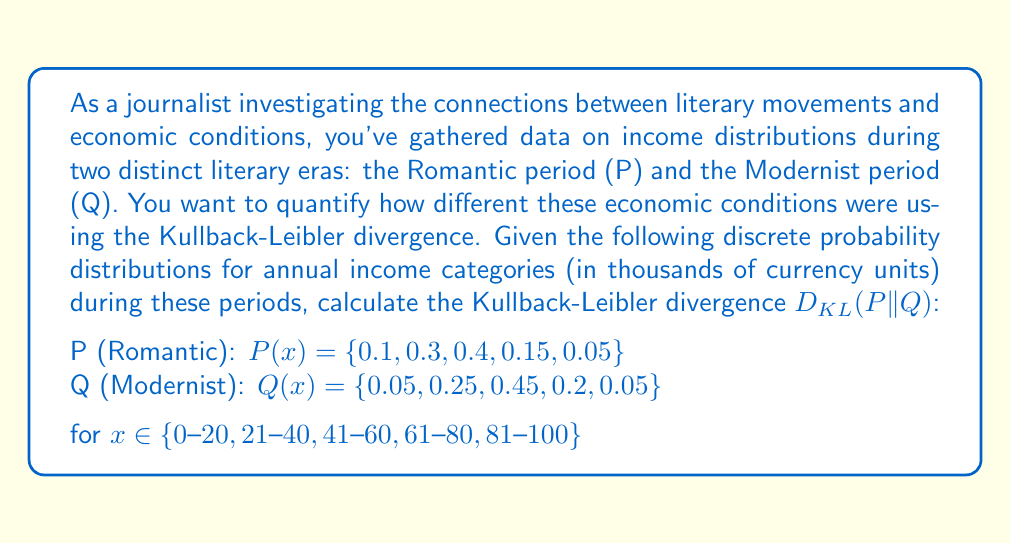Provide a solution to this math problem. To solve this problem, we'll use the formula for Kullback-Leibler divergence for discrete probability distributions:

$$D_{KL}(P||Q) = \sum_{i} P(i) \log\left(\frac{P(i)}{Q(i)}\right)$$

Let's calculate this step-by-step:

1) First, we'll calculate $\frac{P(i)}{Q(i)}$ for each income category:

   $\frac{0.1}{0.05} = 2$
   $\frac{0.3}{0.25} = 1.2$
   $\frac{0.4}{0.45} \approx 0.8889$
   $\frac{0.15}{0.2} = 0.75$
   $\frac{0.05}{0.05} = 1$

2) Now, we'll calculate $\log\left(\frac{P(i)}{Q(i)}\right)$ for each category:

   $\log(2) \approx 0.6931$
   $\log(1.2) \approx 0.1823$
   $\log(0.8889) \approx -0.1178$
   $\log(0.75) \approx -0.2877$
   $\log(1) = 0$

3) Next, we'll multiply each result by its corresponding $P(i)$ and sum:

   $0.1 \cdot 0.6931 = 0.06931$
   $0.3 \cdot 0.1823 = 0.05469$
   $0.4 \cdot (-0.1178) = -0.04712$
   $0.15 \cdot (-0.2877) = -0.043155$
   $0.05 \cdot 0 = 0$

4) Finally, we sum all these values:

   $0.06931 + 0.05469 + (-0.04712) + (-0.043155) + 0 = 0.033725$

Therefore, the Kullback-Leibler divergence $D_{KL}(P||Q)$ is approximately 0.033725.

This value quantifies the information lost when the Modernist income distribution (Q) is used to approximate the Romantic income distribution (P). The relatively small value suggests that while there are differences between the two distributions, they are not dramatically different in terms of information content.
Answer: $D_{KL}(P||Q) \approx 0.033725$ 